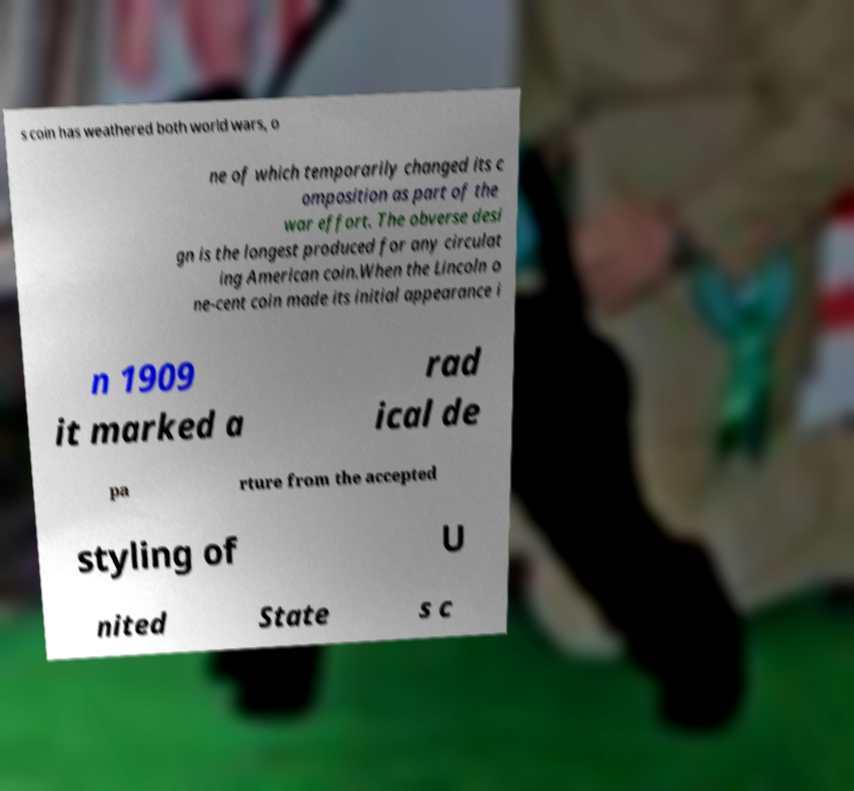Please read and relay the text visible in this image. What does it say? s coin has weathered both world wars, o ne of which temporarily changed its c omposition as part of the war effort. The obverse desi gn is the longest produced for any circulat ing American coin.When the Lincoln o ne-cent coin made its initial appearance i n 1909 it marked a rad ical de pa rture from the accepted styling of U nited State s c 